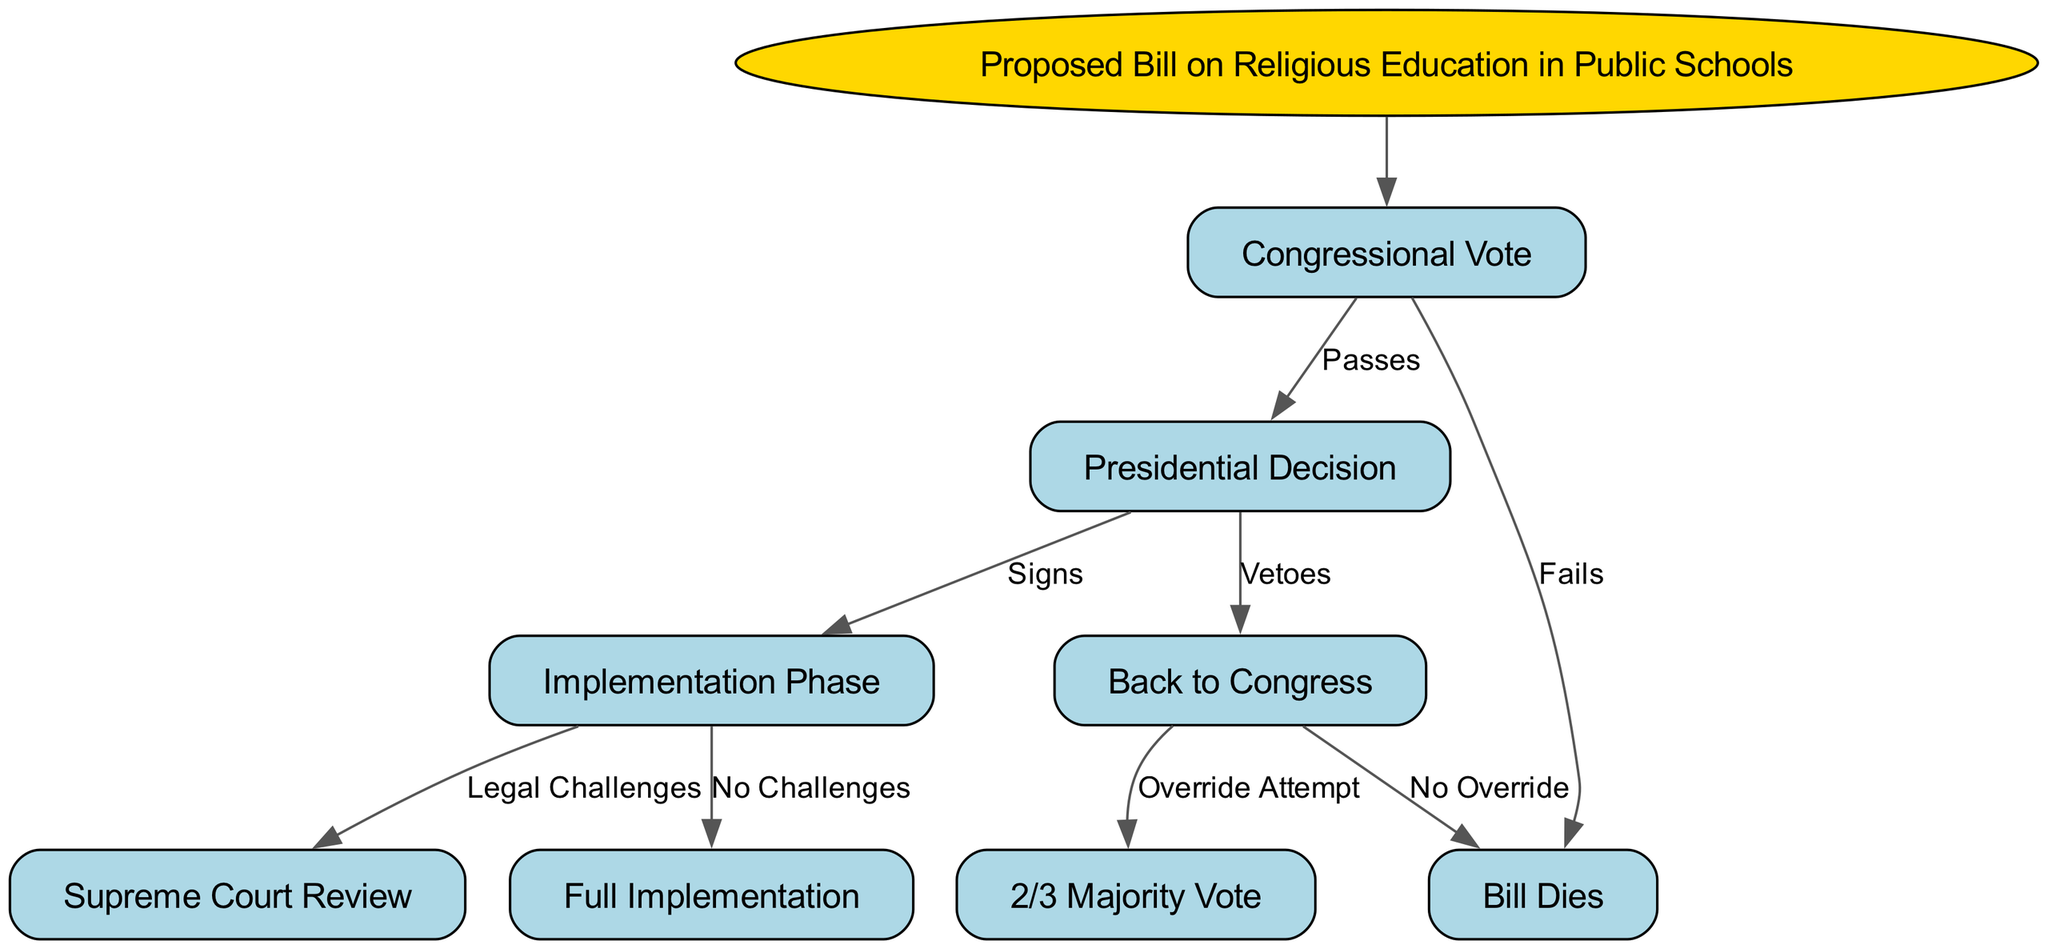What is the initial proposal in this decision tree? The root node of the decision tree clearly states that the initial proposal is "Proposed Bill on Religious Education in Public Schools," as it is the starting point for further decisions.
Answer: Proposed Bill on Religious Education in Public Schools How many outcomes are there for Congressional Vote? The node "Congressional Vote" branches into two outcomes: "Passes" and "Fails," indicating there are two possible outcomes for this decision.
Answer: 2 What happens if the bill passes? If the bill passes, it leads to the next decision node, "Presidential Decision," which further branches into two outcomes: "Signs" or "Vetoes." This indicates the available paths following a successful vote.
Answer: Presidential Decision What are the possible actions taken if the President vetoes the bill? If the President vetoes the bill, there are two subsequent paths: one leading to "Override Attempt" and another leading to "No Override," illustrating the choices available after a veto.
Answer: Override Attempt and No Override What can occur during the Implementation Phase? The "Implementation Phase" node branches into two outcomes: "Legal Challenges" and "No Challenges," which delineate the subsequent events that could follow the phase of implementation.
Answer: Legal Challenges and No Challenges What is the outcome if the bill fails during the Congressional Vote? According to the diagram, if the Congressional Vote fails, the direct outcome is that "Bill Dies," indicating a definitive endpoint for that path in the decision tree.
Answer: Bill Dies What is required for the bill to be reconsidered after a veto? Should the bill be vetoed, for it to be reconsidered, a "2/3 Majority Vote" is required to override the veto, as indicated by the respective node that follows the veto action.
Answer: 2/3 Majority Vote How many total decision nodes are present in the diagram? Counting from the root and including all nodes that represent decisions, the diagram shows a total of five decision nodes: one root and four subsequent decisions leading to various outcomes.
Answer: 5 What potential event follows "No Challenges"? If there are "No Challenges" during the implementation, the next step indicated is "Full Implementation," signaling the successful realization of the bill's provisions without legal hindrance.
Answer: Full Implementation What indicates the final outcome for the bill? The node "Bill Dies" indicates a definitive end for the proposed legislation, marking a point in the decision tree where no further actions or outcomes can occur for the bill.
Answer: Bill Dies 